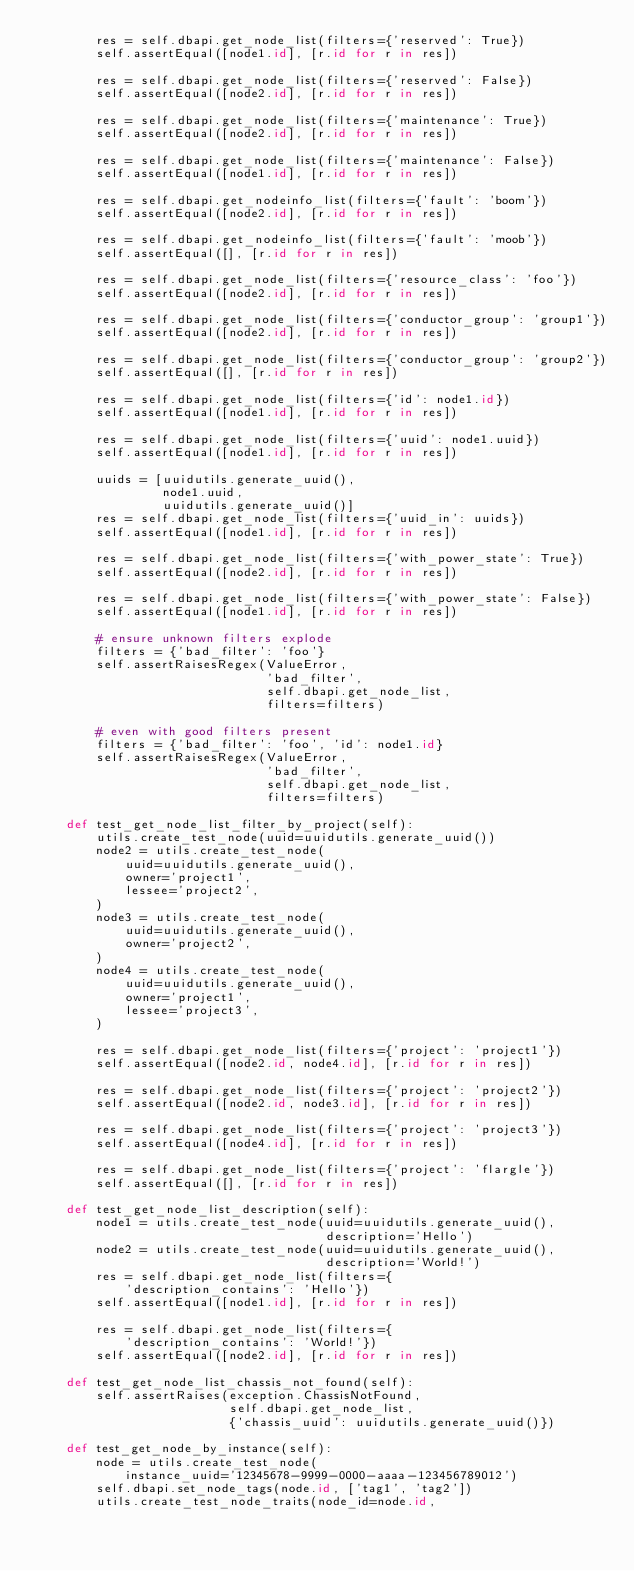<code> <loc_0><loc_0><loc_500><loc_500><_Python_>        res = self.dbapi.get_node_list(filters={'reserved': True})
        self.assertEqual([node1.id], [r.id for r in res])

        res = self.dbapi.get_node_list(filters={'reserved': False})
        self.assertEqual([node2.id], [r.id for r in res])

        res = self.dbapi.get_node_list(filters={'maintenance': True})
        self.assertEqual([node2.id], [r.id for r in res])

        res = self.dbapi.get_node_list(filters={'maintenance': False})
        self.assertEqual([node1.id], [r.id for r in res])

        res = self.dbapi.get_nodeinfo_list(filters={'fault': 'boom'})
        self.assertEqual([node2.id], [r.id for r in res])

        res = self.dbapi.get_nodeinfo_list(filters={'fault': 'moob'})
        self.assertEqual([], [r.id for r in res])

        res = self.dbapi.get_node_list(filters={'resource_class': 'foo'})
        self.assertEqual([node2.id], [r.id for r in res])

        res = self.dbapi.get_node_list(filters={'conductor_group': 'group1'})
        self.assertEqual([node2.id], [r.id for r in res])

        res = self.dbapi.get_node_list(filters={'conductor_group': 'group2'})
        self.assertEqual([], [r.id for r in res])

        res = self.dbapi.get_node_list(filters={'id': node1.id})
        self.assertEqual([node1.id], [r.id for r in res])

        res = self.dbapi.get_node_list(filters={'uuid': node1.uuid})
        self.assertEqual([node1.id], [r.id for r in res])

        uuids = [uuidutils.generate_uuid(),
                 node1.uuid,
                 uuidutils.generate_uuid()]
        res = self.dbapi.get_node_list(filters={'uuid_in': uuids})
        self.assertEqual([node1.id], [r.id for r in res])

        res = self.dbapi.get_node_list(filters={'with_power_state': True})
        self.assertEqual([node2.id], [r.id for r in res])

        res = self.dbapi.get_node_list(filters={'with_power_state': False})
        self.assertEqual([node1.id], [r.id for r in res])

        # ensure unknown filters explode
        filters = {'bad_filter': 'foo'}
        self.assertRaisesRegex(ValueError,
                               'bad_filter',
                               self.dbapi.get_node_list,
                               filters=filters)

        # even with good filters present
        filters = {'bad_filter': 'foo', 'id': node1.id}
        self.assertRaisesRegex(ValueError,
                               'bad_filter',
                               self.dbapi.get_node_list,
                               filters=filters)

    def test_get_node_list_filter_by_project(self):
        utils.create_test_node(uuid=uuidutils.generate_uuid())
        node2 = utils.create_test_node(
            uuid=uuidutils.generate_uuid(),
            owner='project1',
            lessee='project2',
        )
        node3 = utils.create_test_node(
            uuid=uuidutils.generate_uuid(),
            owner='project2',
        )
        node4 = utils.create_test_node(
            uuid=uuidutils.generate_uuid(),
            owner='project1',
            lessee='project3',
        )

        res = self.dbapi.get_node_list(filters={'project': 'project1'})
        self.assertEqual([node2.id, node4.id], [r.id for r in res])

        res = self.dbapi.get_node_list(filters={'project': 'project2'})
        self.assertEqual([node2.id, node3.id], [r.id for r in res])

        res = self.dbapi.get_node_list(filters={'project': 'project3'})
        self.assertEqual([node4.id], [r.id for r in res])

        res = self.dbapi.get_node_list(filters={'project': 'flargle'})
        self.assertEqual([], [r.id for r in res])

    def test_get_node_list_description(self):
        node1 = utils.create_test_node(uuid=uuidutils.generate_uuid(),
                                       description='Hello')
        node2 = utils.create_test_node(uuid=uuidutils.generate_uuid(),
                                       description='World!')
        res = self.dbapi.get_node_list(filters={
            'description_contains': 'Hello'})
        self.assertEqual([node1.id], [r.id for r in res])

        res = self.dbapi.get_node_list(filters={
            'description_contains': 'World!'})
        self.assertEqual([node2.id], [r.id for r in res])

    def test_get_node_list_chassis_not_found(self):
        self.assertRaises(exception.ChassisNotFound,
                          self.dbapi.get_node_list,
                          {'chassis_uuid': uuidutils.generate_uuid()})

    def test_get_node_by_instance(self):
        node = utils.create_test_node(
            instance_uuid='12345678-9999-0000-aaaa-123456789012')
        self.dbapi.set_node_tags(node.id, ['tag1', 'tag2'])
        utils.create_test_node_traits(node_id=node.id,</code> 